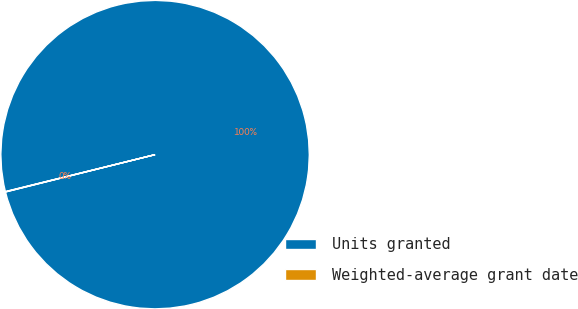Convert chart to OTSL. <chart><loc_0><loc_0><loc_500><loc_500><pie_chart><fcel>Units granted<fcel>Weighted-average grant date<nl><fcel>99.96%<fcel>0.04%<nl></chart> 